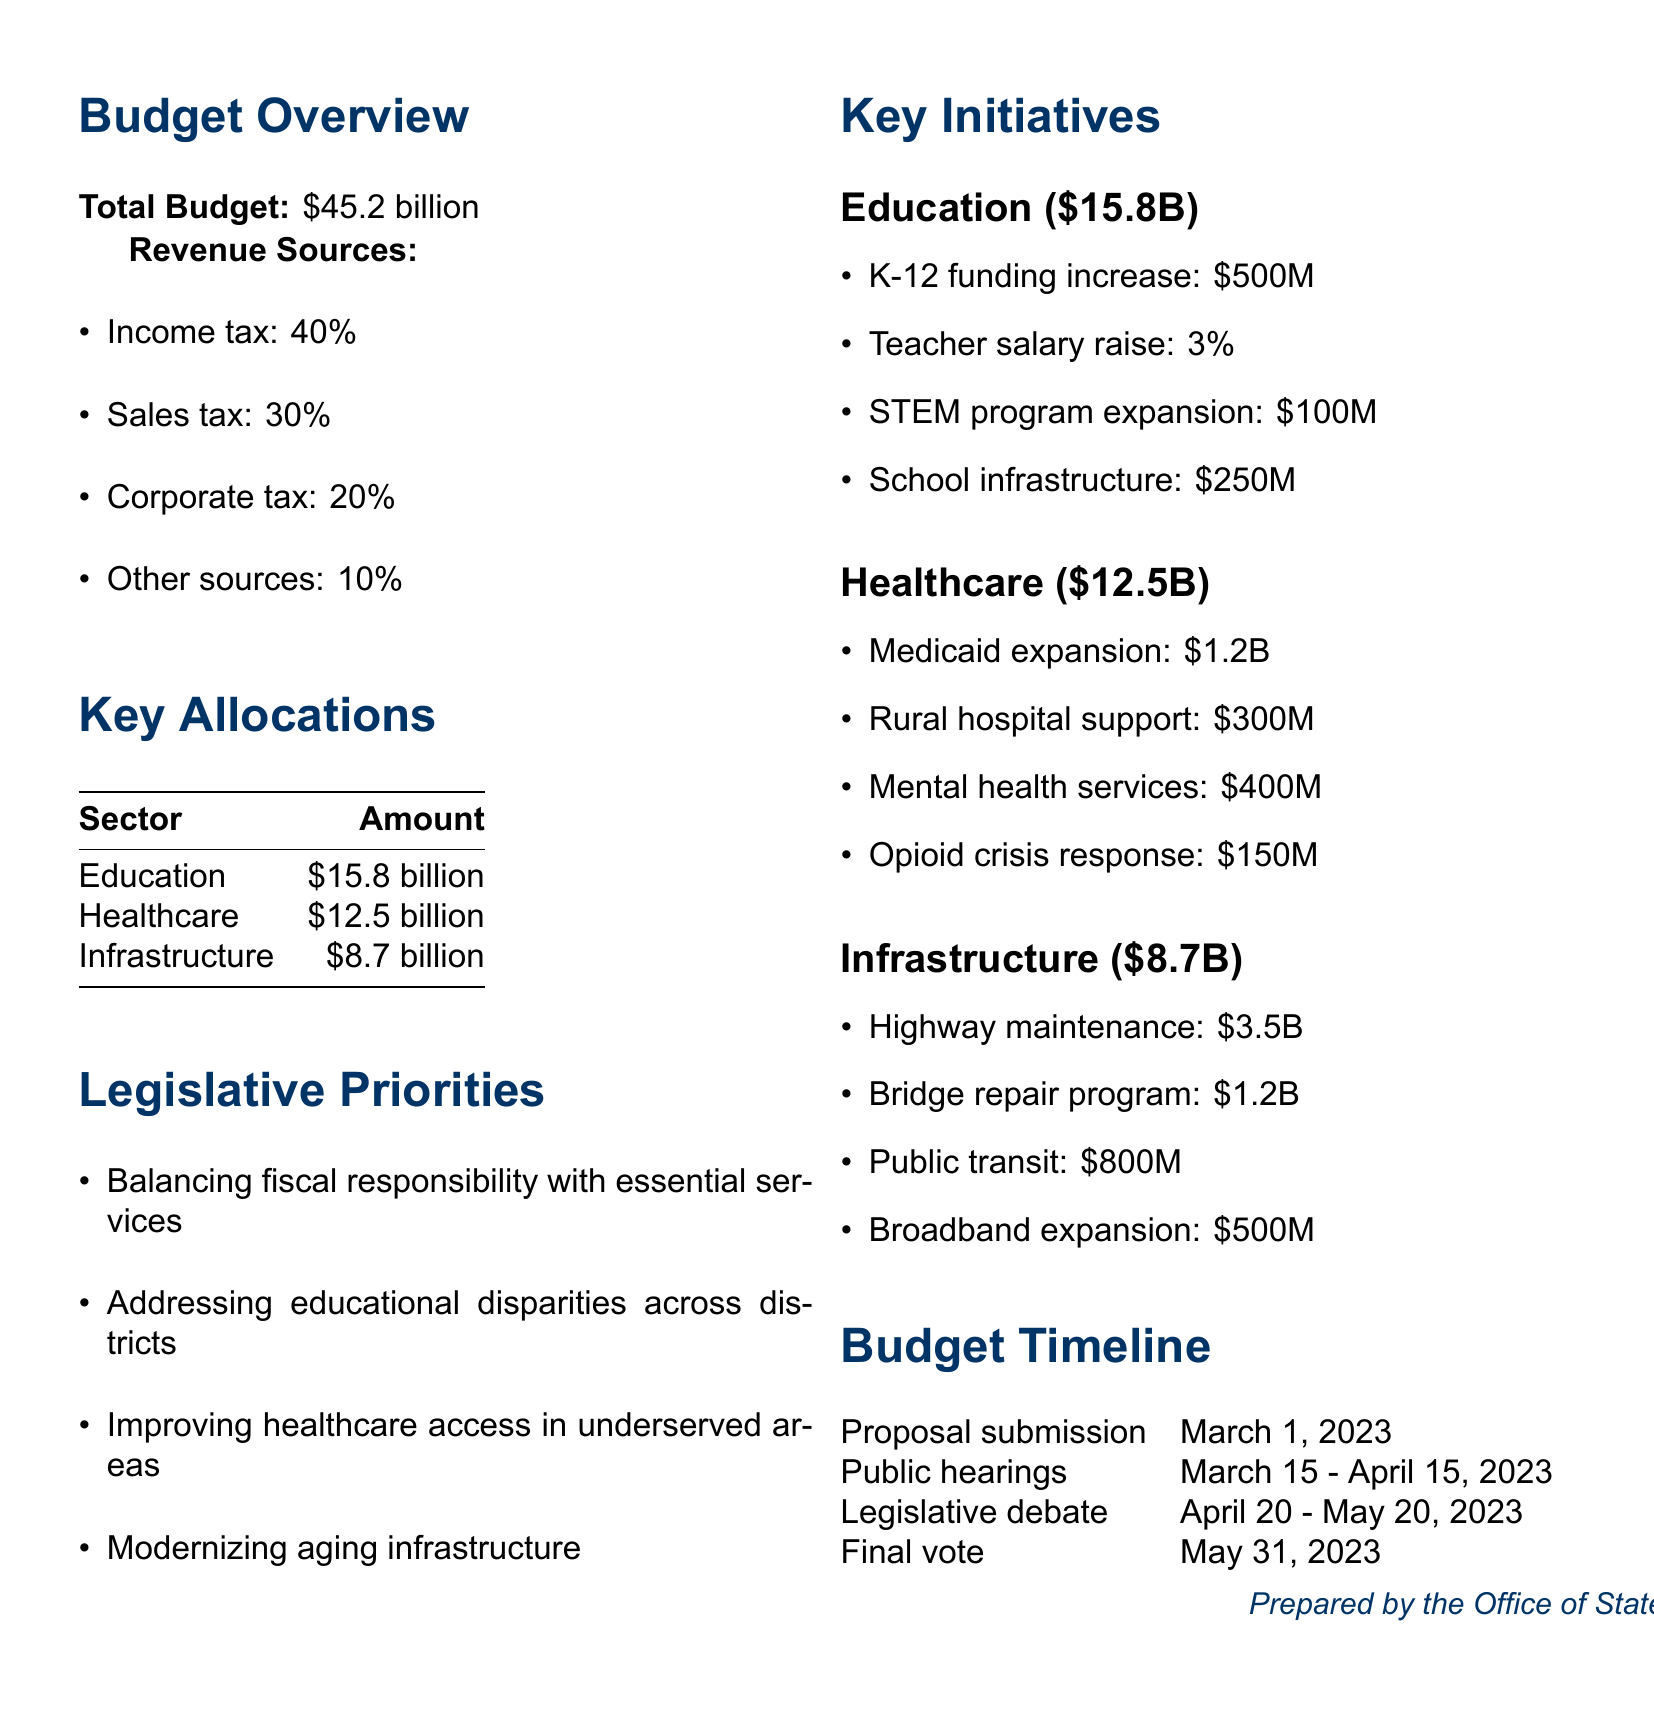What is the total budget? The total budget is stated clearly in the document as \$45.2 billion.
Answer: \$45.2 billion How much is allocated for healthcare? The document specifies that the allocation for healthcare is \$12.5 billion.
Answer: \$12.5 billion What percentage of the revenue comes from income tax? The document lists income tax as contributing 40% of the total revenue.
Answer: 40% When is the final vote scheduled? According to the budget timeline, the final vote is scheduled for May 31, 2023.
Answer: May 31, 2023 What amount is dedicated to K-12 funding increase? The document indicates that \$500 million is allocated for the K-12 funding increase.
Answer: \$500M What is one of the legislative priorities mentioned? The document lists several priorities, one of which is addressing educational disparities across districts.
Answer: Addressing educational disparities across districts How much is earmarked for highway maintenance? The allocation for highway maintenance is specified as \$3.5 billion in the infrastructure section.
Answer: \$3.5B What is the total allocation for infrastructure? The total amount dedicated to infrastructure is stated as \$8.7 billion.
Answer: \$8.7 billion 